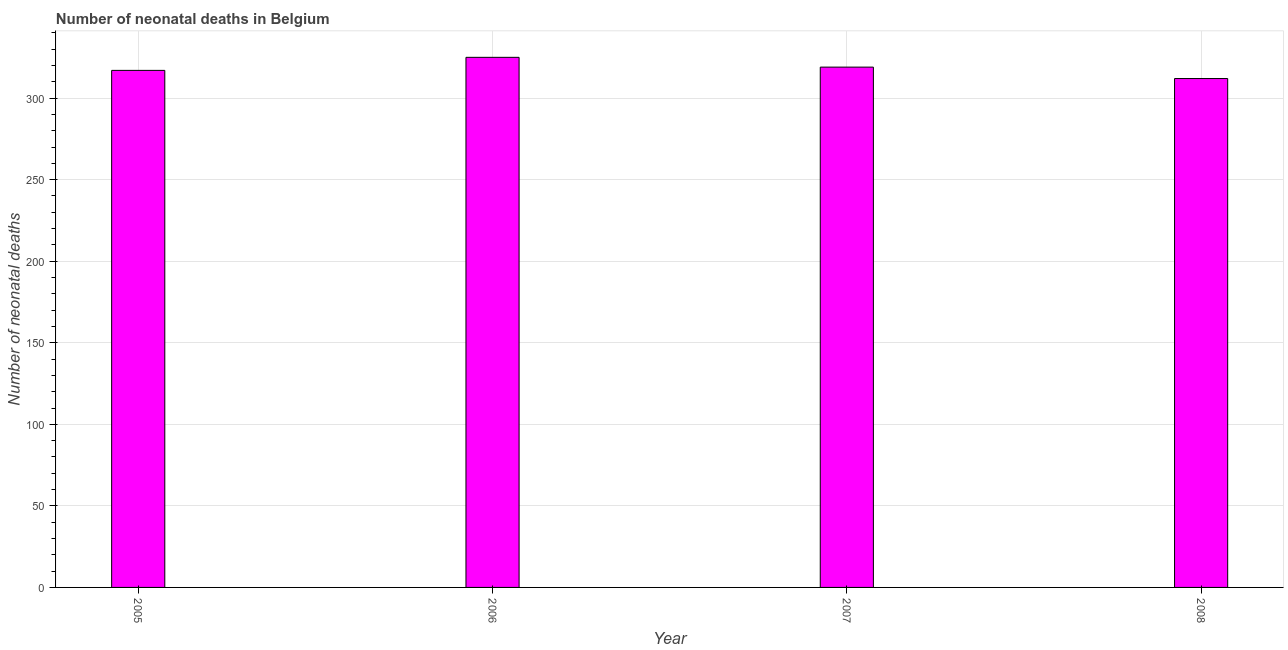Does the graph contain any zero values?
Keep it short and to the point. No. Does the graph contain grids?
Make the answer very short. Yes. What is the title of the graph?
Your answer should be compact. Number of neonatal deaths in Belgium. What is the label or title of the X-axis?
Give a very brief answer. Year. What is the label or title of the Y-axis?
Provide a short and direct response. Number of neonatal deaths. What is the number of neonatal deaths in 2005?
Provide a succinct answer. 317. Across all years, what is the maximum number of neonatal deaths?
Ensure brevity in your answer.  325. Across all years, what is the minimum number of neonatal deaths?
Provide a short and direct response. 312. In which year was the number of neonatal deaths maximum?
Offer a terse response. 2006. In which year was the number of neonatal deaths minimum?
Provide a short and direct response. 2008. What is the sum of the number of neonatal deaths?
Provide a succinct answer. 1273. What is the difference between the number of neonatal deaths in 2006 and 2008?
Provide a succinct answer. 13. What is the average number of neonatal deaths per year?
Ensure brevity in your answer.  318. What is the median number of neonatal deaths?
Give a very brief answer. 318. What is the ratio of the number of neonatal deaths in 2006 to that in 2007?
Offer a very short reply. 1.02. What is the difference between the highest and the lowest number of neonatal deaths?
Ensure brevity in your answer.  13. In how many years, is the number of neonatal deaths greater than the average number of neonatal deaths taken over all years?
Give a very brief answer. 2. How many bars are there?
Your answer should be very brief. 4. Are all the bars in the graph horizontal?
Offer a very short reply. No. How many years are there in the graph?
Your response must be concise. 4. What is the difference between two consecutive major ticks on the Y-axis?
Your answer should be very brief. 50. What is the Number of neonatal deaths in 2005?
Offer a terse response. 317. What is the Number of neonatal deaths in 2006?
Offer a very short reply. 325. What is the Number of neonatal deaths of 2007?
Your answer should be very brief. 319. What is the Number of neonatal deaths of 2008?
Make the answer very short. 312. What is the difference between the Number of neonatal deaths in 2005 and 2006?
Give a very brief answer. -8. What is the difference between the Number of neonatal deaths in 2006 and 2007?
Provide a short and direct response. 6. What is the difference between the Number of neonatal deaths in 2006 and 2008?
Offer a very short reply. 13. What is the difference between the Number of neonatal deaths in 2007 and 2008?
Give a very brief answer. 7. What is the ratio of the Number of neonatal deaths in 2006 to that in 2008?
Make the answer very short. 1.04. What is the ratio of the Number of neonatal deaths in 2007 to that in 2008?
Keep it short and to the point. 1.02. 